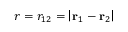Convert formula to latex. <formula><loc_0><loc_0><loc_500><loc_500>r = r _ { 1 2 } = \left | r _ { 1 } - r _ { 2 } \right |</formula> 